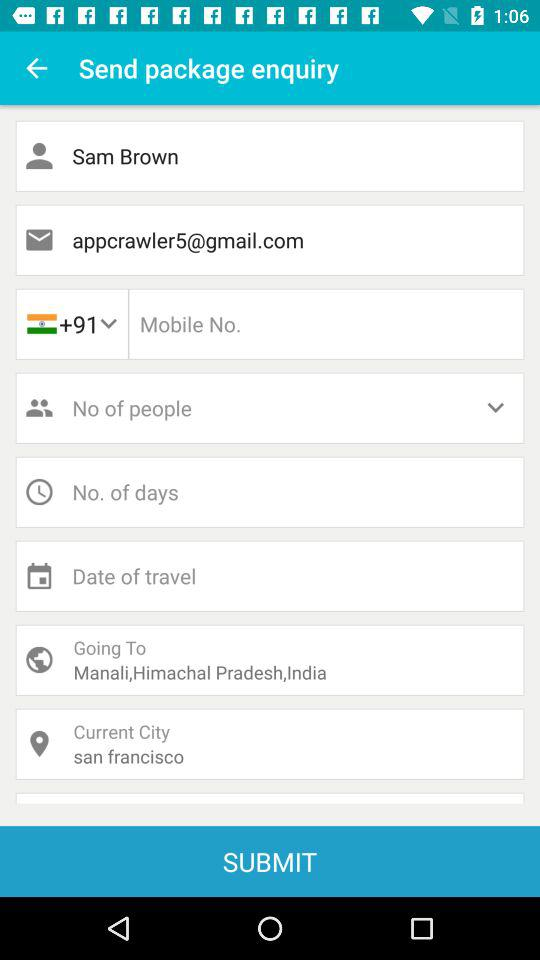What is the email address? The email address is appcrawler5@gmail.com. 